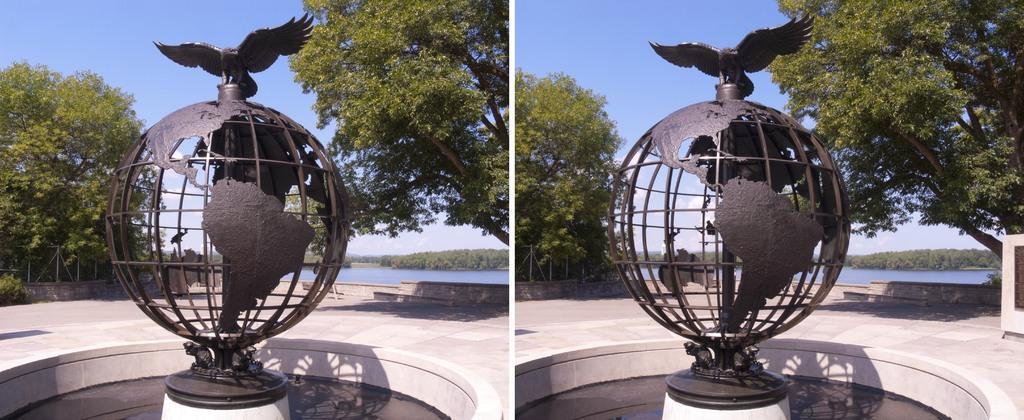Please provide a concise description of this image. In this picture I can see there is a statue of a globe and it has a eagle on it. There is a lake, trees, plants and the sky is clear. 